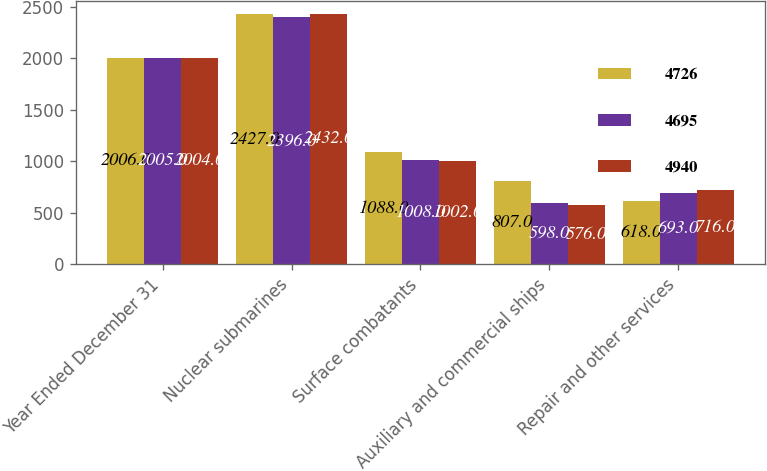<chart> <loc_0><loc_0><loc_500><loc_500><stacked_bar_chart><ecel><fcel>Year Ended December 31<fcel>Nuclear submarines<fcel>Surface combatants<fcel>Auxiliary and commercial ships<fcel>Repair and other services<nl><fcel>4726<fcel>2006<fcel>2427<fcel>1088<fcel>807<fcel>618<nl><fcel>4695<fcel>2005<fcel>2396<fcel>1008<fcel>598<fcel>693<nl><fcel>4940<fcel>2004<fcel>2432<fcel>1002<fcel>576<fcel>716<nl></chart> 